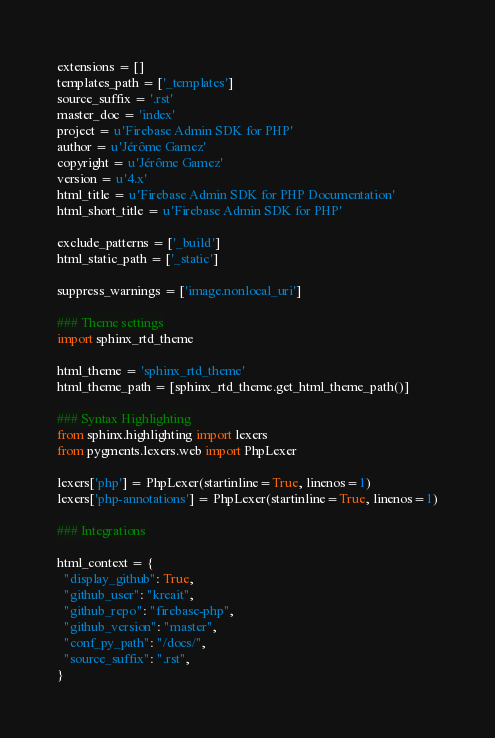Convert code to text. <code><loc_0><loc_0><loc_500><loc_500><_Python_>
extensions = []
templates_path = ['_templates']
source_suffix = '.rst'
master_doc = 'index'
project = u'Firebase Admin SDK for PHP'
author = u'Jérôme Gamez'
copyright = u'Jérôme Gamez'
version = u'4.x'
html_title = u'Firebase Admin SDK for PHP Documentation'
html_short_title = u'Firebase Admin SDK for PHP'

exclude_patterns = ['_build']
html_static_path = ['_static']

suppress_warnings = ['image.nonlocal_uri']

### Theme settings
import sphinx_rtd_theme

html_theme = 'sphinx_rtd_theme'
html_theme_path = [sphinx_rtd_theme.get_html_theme_path()]

### Syntax Highlighting
from sphinx.highlighting import lexers
from pygments.lexers.web import PhpLexer

lexers['php'] = PhpLexer(startinline=True, linenos=1)
lexers['php-annotations'] = PhpLexer(startinline=True, linenos=1)

### Integrations

html_context = {
  "display_github": True,
  "github_user": "kreait",
  "github_repo": "firebase-php",
  "github_version": "master",
  "conf_py_path": "/docs/",
  "source_suffix": ".rst",
}
</code> 